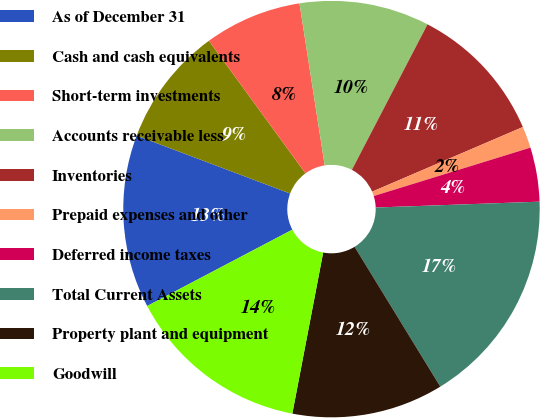Convert chart to OTSL. <chart><loc_0><loc_0><loc_500><loc_500><pie_chart><fcel>As of December 31<fcel>Cash and cash equivalents<fcel>Short-term investments<fcel>Accounts receivable less<fcel>Inventories<fcel>Prepaid expenses and other<fcel>Deferred income taxes<fcel>Total Current Assets<fcel>Property plant and equipment<fcel>Goodwill<nl><fcel>13.44%<fcel>9.24%<fcel>7.56%<fcel>10.08%<fcel>10.92%<fcel>1.68%<fcel>4.2%<fcel>16.81%<fcel>11.76%<fcel>14.28%<nl></chart> 